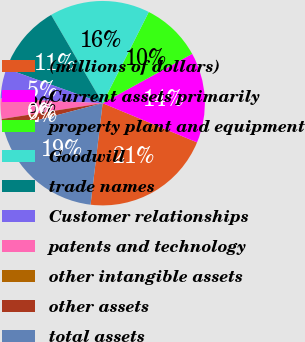<chart> <loc_0><loc_0><loc_500><loc_500><pie_chart><fcel>(millions of dollars)<fcel>Current assets primarily<fcel>property plant and equipment<fcel>Goodwill<fcel>trade names<fcel>Customer relationships<fcel>patents and technology<fcel>other intangible assets<fcel>other assets<fcel>total assets<nl><fcel>20.62%<fcel>14.28%<fcel>9.52%<fcel>15.86%<fcel>11.11%<fcel>4.77%<fcel>3.18%<fcel>0.01%<fcel>1.6%<fcel>19.03%<nl></chart> 